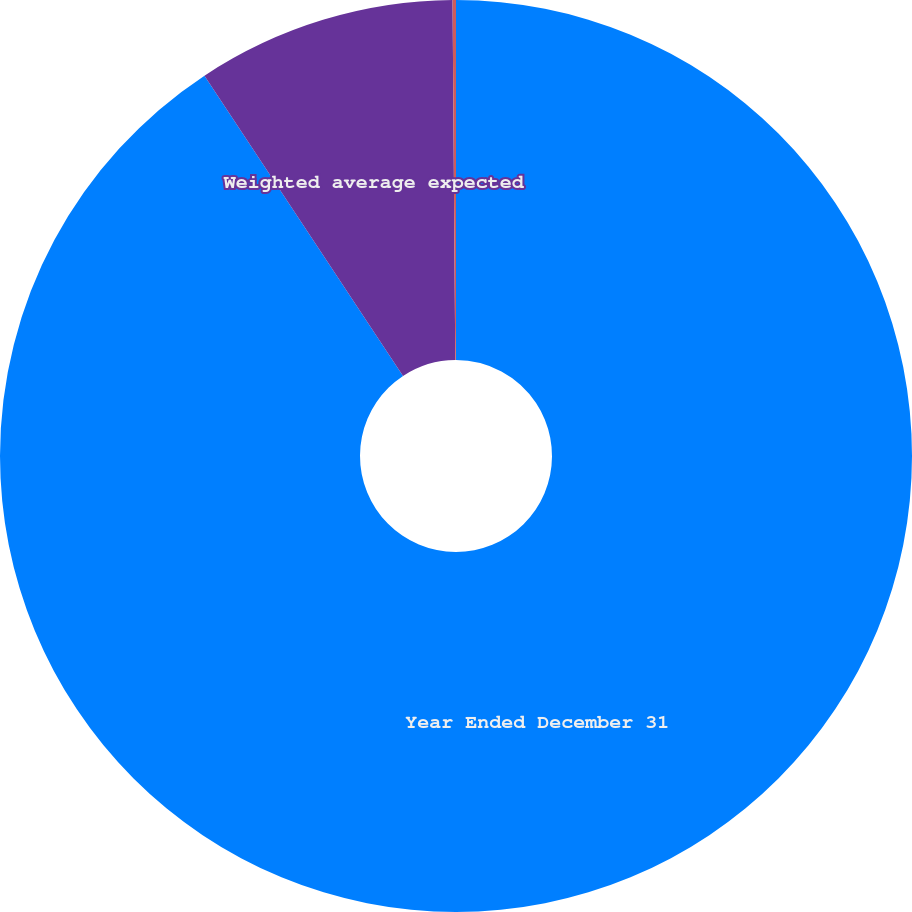Convert chart. <chart><loc_0><loc_0><loc_500><loc_500><pie_chart><fcel>Year Ended December 31<fcel>Weighted average expected<fcel>Expected dividend yield<nl><fcel>90.7%<fcel>9.18%<fcel>0.12%<nl></chart> 